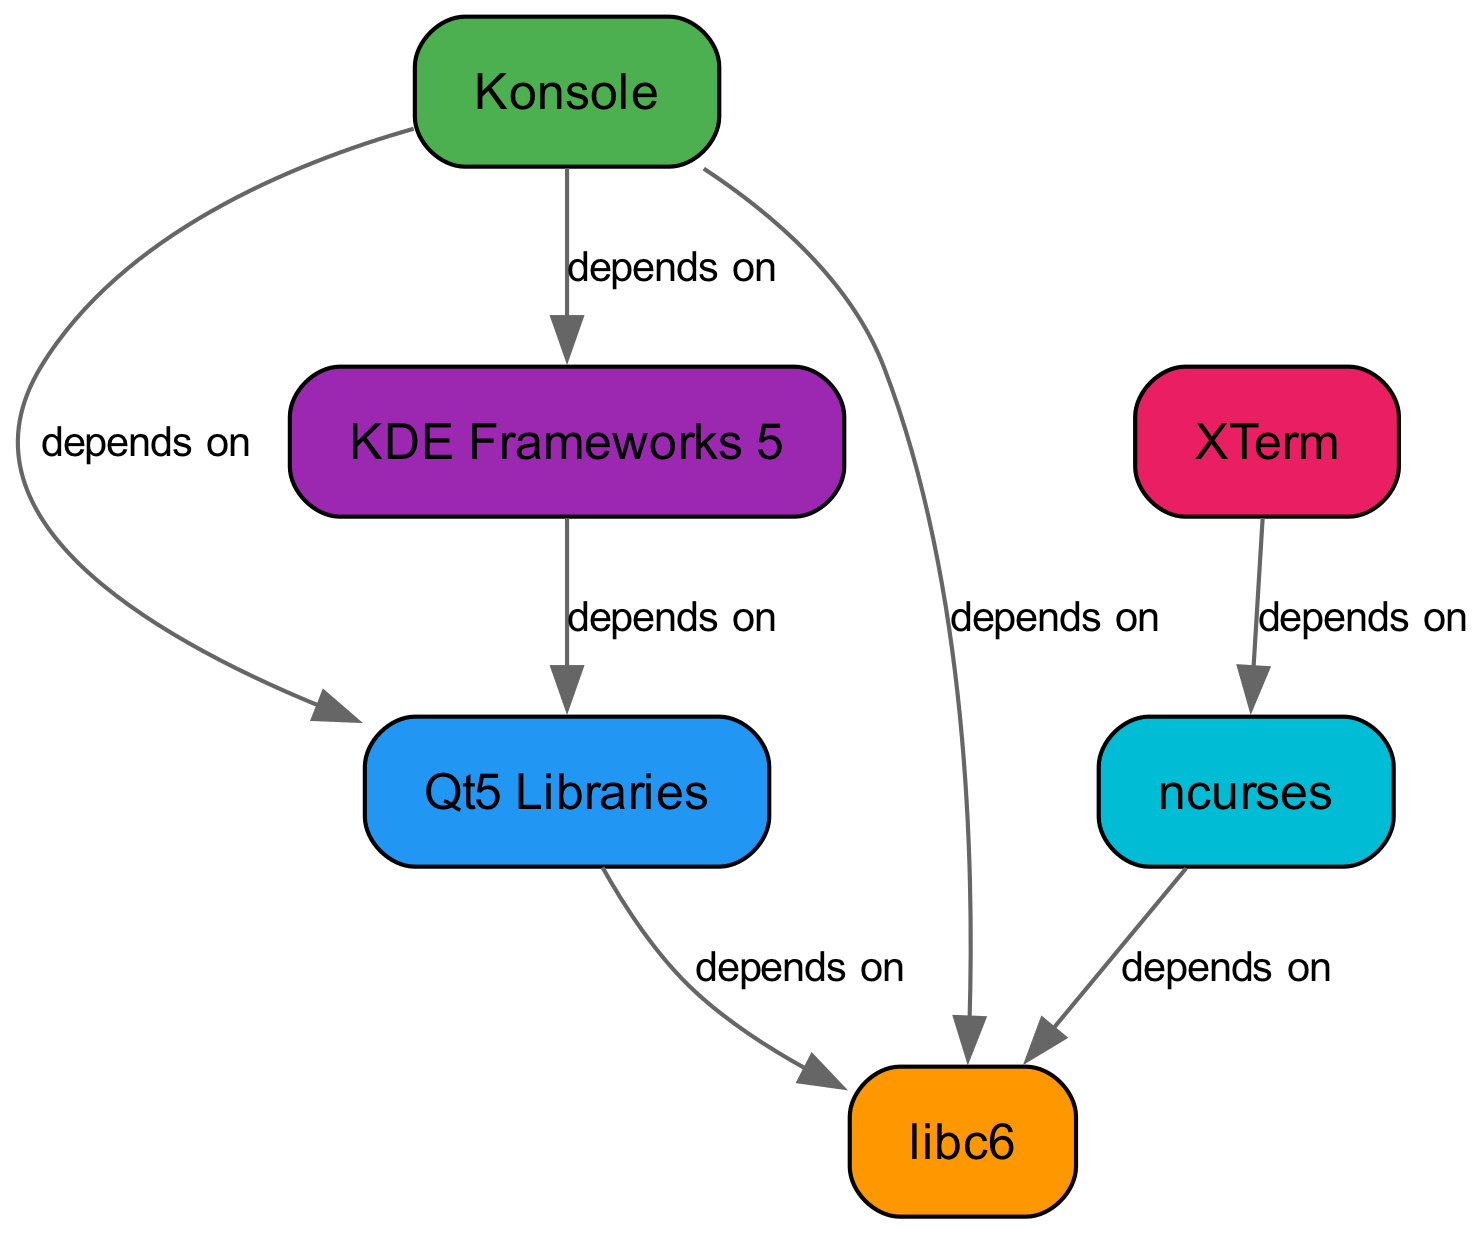What's the total number of nodes in the diagram? The diagram lists six nodes: Konsole, Qt5 Libraries, KDE Frameworks 5, libc6, XTerm, and ncurses. Counting these gives a total of six nodes.
Answer: Six How many edges are there in the diagram? The diagram has seven edges, representing the dependencies between the nodes. Each is counted by identifying the lines connecting the nodes.
Answer: Seven What does Konsole depend on? The diagram shows three dependencies for Konsole: Qt5 Libraries, KDE Frameworks 5, and libc6. Each dependency is illustrated as an edge stemming from Konsole.
Answer: Qt5 Libraries, KDE Frameworks 5, libc6 Which node is directly dependent on Qt5 Libraries? The edge from Qt5 Libraries leads to libc6, indicating that libc6 is directly dependent on Qt5 Libraries as per the dependency connections shown.
Answer: libc6 What is the relationship between ncurses and libc6? According to the diagram, there is a directed edge from ncurses to libc6, indicating that ncurses depends on libc6. The connection shows the dependency flow clearly.
Answer: depends on How many nodes does KDE Frameworks 5 depend on? The diagram indicates that KDE Frameworks 5 has one direct dependency, which is Qt5 Libraries, by counting the edges that stem from KDE Frameworks 5.
Answer: One What nodes does XTerm depend on? The diagram shows that XTerm has one dependency, which is ncurses. This is determined from the directed edge linking XTerm to ncurses.
Answer: ncurses Which node has the most dependencies? By analyzing the edges, Konsole has three dependencies while others have fewer. Thus, it has the most connections representing dependencies among the nodes.
Answer: Konsole Is libc6 a dependency for both Konsole and ncurses? The diagram illustrates that both Konsole and ncurses have edges leading to libc6, confirming it as a common dependency.
Answer: Yes 